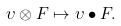Convert formula to latex. <formula><loc_0><loc_0><loc_500><loc_500>\upsilon \otimes F \mapsto \upsilon \bullet F .</formula> 